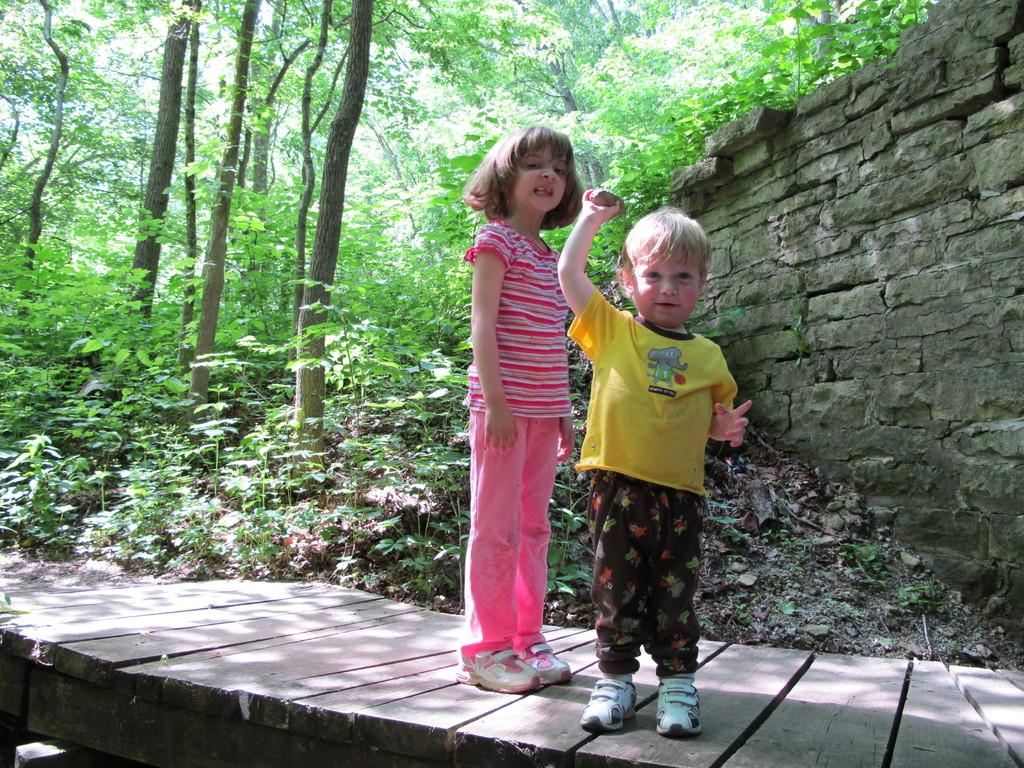How many people are in the image? There are two people in the image. What is the surface that the people are standing on? The people are standing on a wooden surface. What type of vegetation can be seen in the image? There are plants and trees visible in the image. What is in the background of the image? There is a wall in the background of the image. What type of mouth can be seen on the wooden surface in the image? There is no mouth present on the wooden surface in the image. What type of wood is used to make the quince in the image? There is no quince present in the image, and therefore no wood used to make it. 